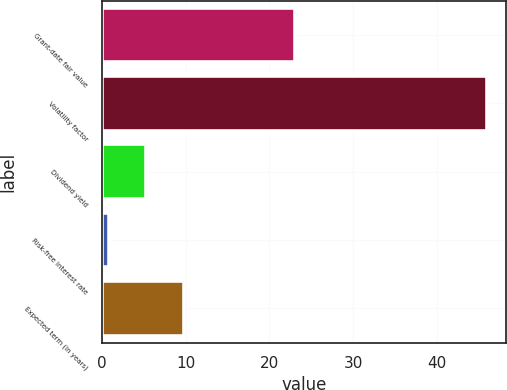Convert chart to OTSL. <chart><loc_0><loc_0><loc_500><loc_500><bar_chart><fcel>Grant-date fair value<fcel>Volatility factor<fcel>Dividend yield<fcel>Risk-free interest rate<fcel>Expected term (in years)<nl><fcel>23.11<fcel>46<fcel>5.32<fcel>0.8<fcel>9.84<nl></chart> 